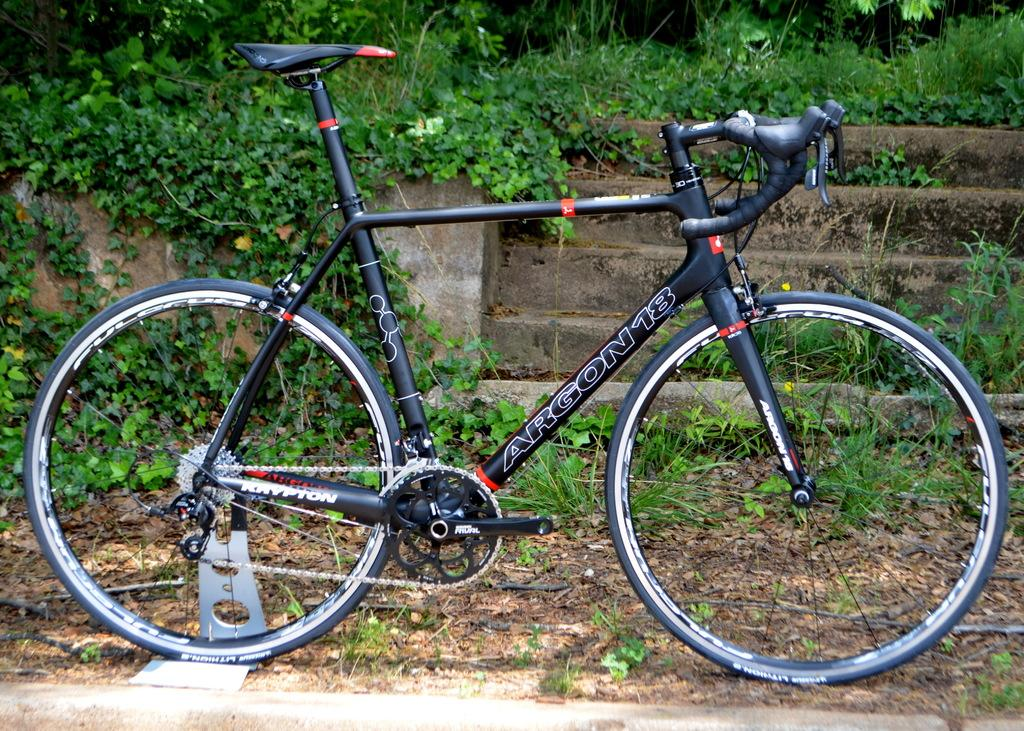What is the main object in the image? There is a bicycle in the image. How is the bicycle positioned in the image? The bicycle is parked on the floor. What can be seen in the background of the image? There are stars and grass visible in the background of the image. Is there a lock securing the bicycle in the image? There is no mention of a lock in the provided facts, so we cannot determine if the bicycle is locked or not. 